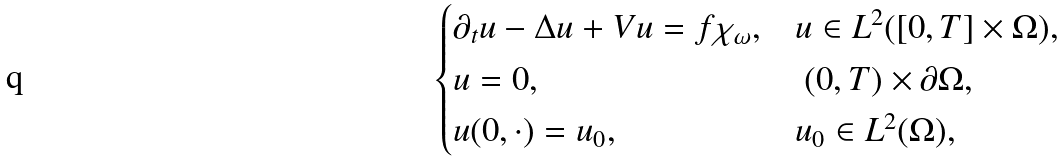<formula> <loc_0><loc_0><loc_500><loc_500>\begin{cases} \partial _ { t } u - \Delta u + V u = f \chi _ { \omega } , & u \in L ^ { 2 } ( [ 0 , T ] \times \Omega ) , \\ u = 0 , & \ ( 0 , T ) \times \partial \Omega , \\ u ( 0 , \cdot ) = u _ { 0 } , & u _ { 0 } \in L ^ { 2 } ( \Omega ) , \end{cases}</formula> 